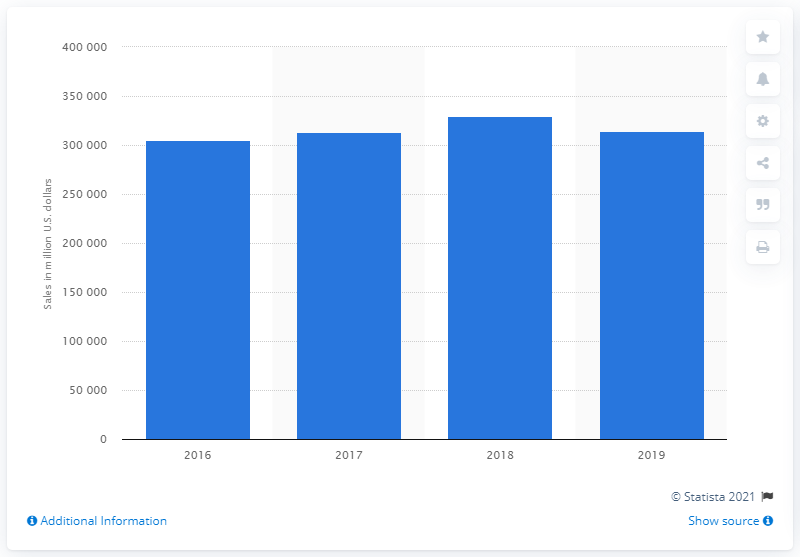Identify some key points in this picture. The revenue generated by the top global automotive suppliers in 2019 was approximately 314,654. 